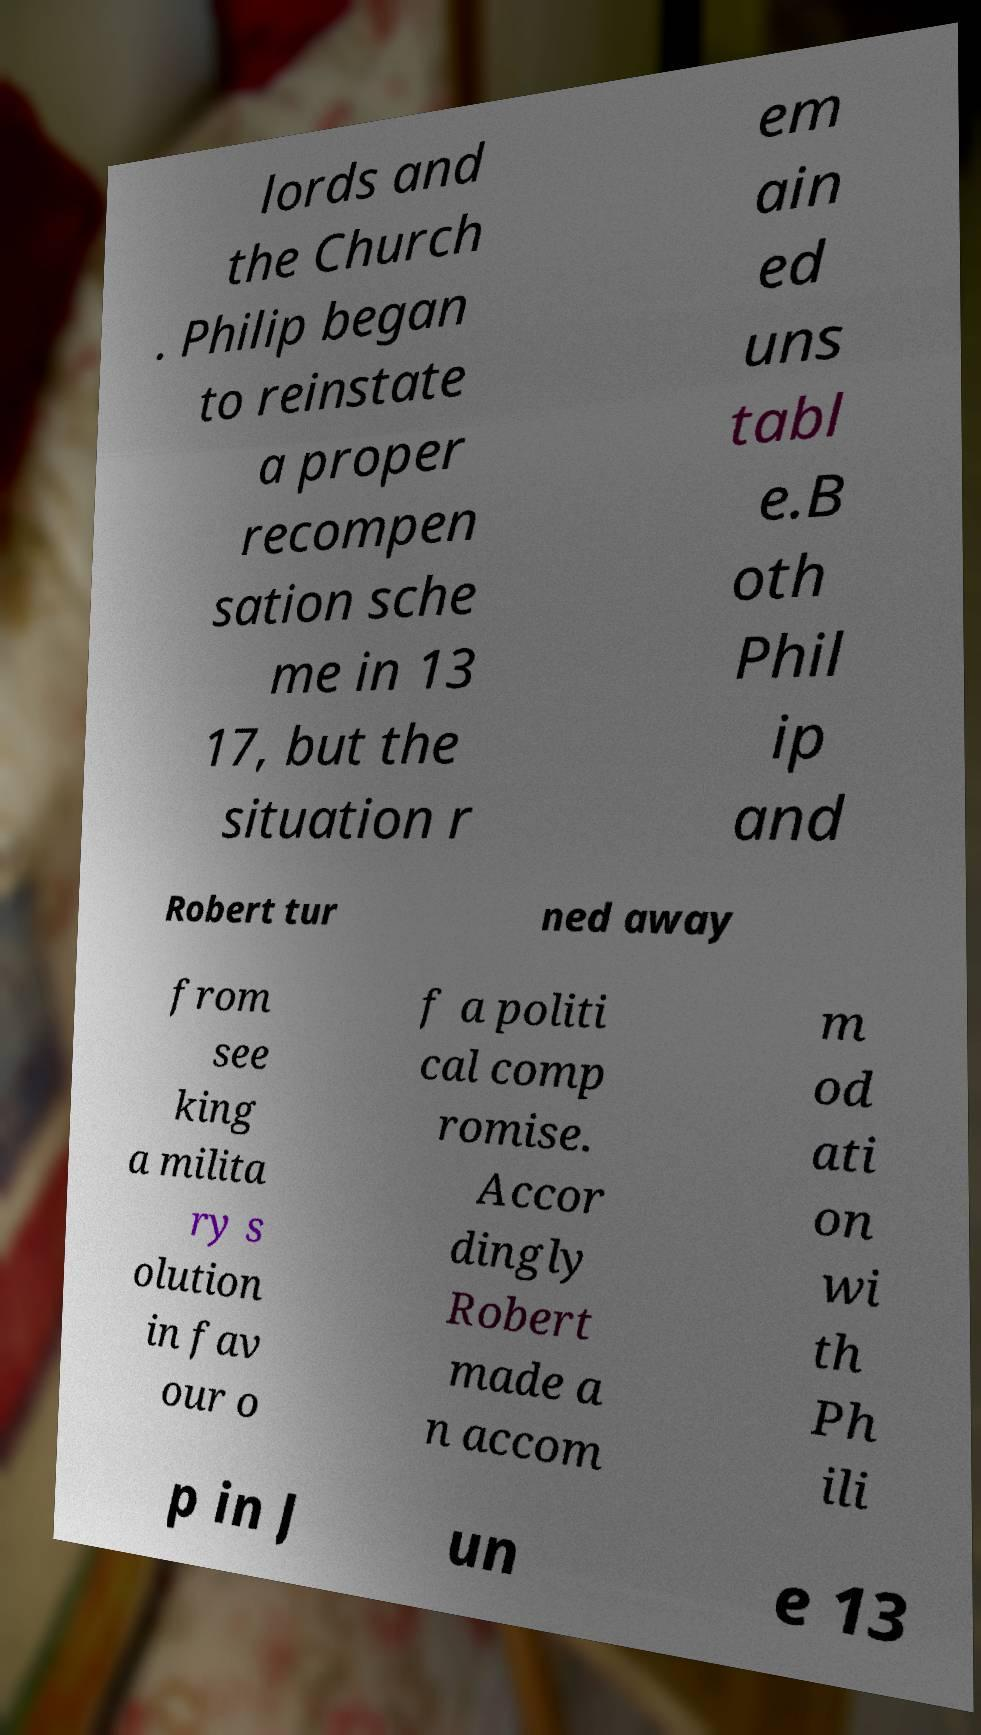Please read and relay the text visible in this image. What does it say? lords and the Church . Philip began to reinstate a proper recompen sation sche me in 13 17, but the situation r em ain ed uns tabl e.B oth Phil ip and Robert tur ned away from see king a milita ry s olution in fav our o f a politi cal comp romise. Accor dingly Robert made a n accom m od ati on wi th Ph ili p in J un e 13 